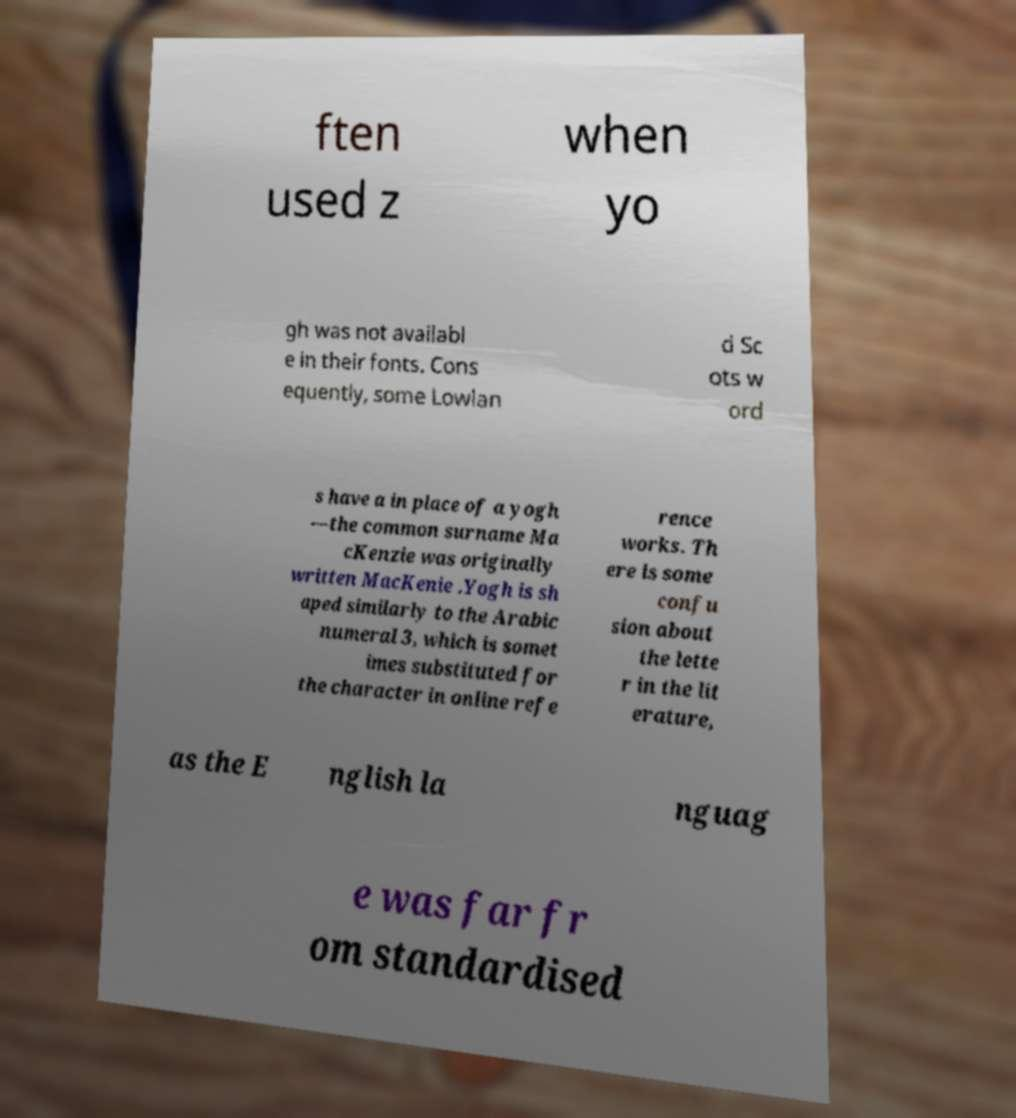There's text embedded in this image that I need extracted. Can you transcribe it verbatim? ften used z when yo gh was not availabl e in their fonts. Cons equently, some Lowlan d Sc ots w ord s have a in place of a yogh —the common surname Ma cKenzie was originally written MacKenie .Yogh is sh aped similarly to the Arabic numeral 3, which is somet imes substituted for the character in online refe rence works. Th ere is some confu sion about the lette r in the lit erature, as the E nglish la nguag e was far fr om standardised 